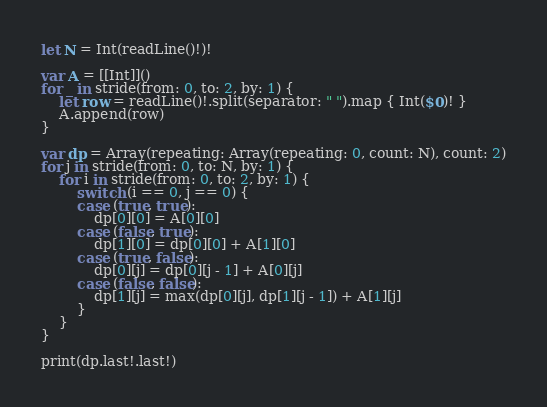<code> <loc_0><loc_0><loc_500><loc_500><_Swift_>let N = Int(readLine()!)!

var A = [[Int]]()
for _ in stride(from: 0, to: 2, by: 1) {
    let row = readLine()!.split(separator: " ").map { Int($0)! }
    A.append(row)
}

var dp = Array(repeating: Array(repeating: 0, count: N), count: 2)
for j in stride(from: 0, to: N, by: 1) {
    for i in stride(from: 0, to: 2, by: 1) {
        switch (i == 0, j == 0) {
        case (true, true):
            dp[0][0] = A[0][0]
        case (false, true):
            dp[1][0] = dp[0][0] + A[1][0]
        case (true, false):
            dp[0][j] = dp[0][j - 1] + A[0][j]
        case (false, false):
            dp[1][j] = max(dp[0][j], dp[1][j - 1]) + A[1][j]
        }
    }
}

print(dp.last!.last!)
</code> 